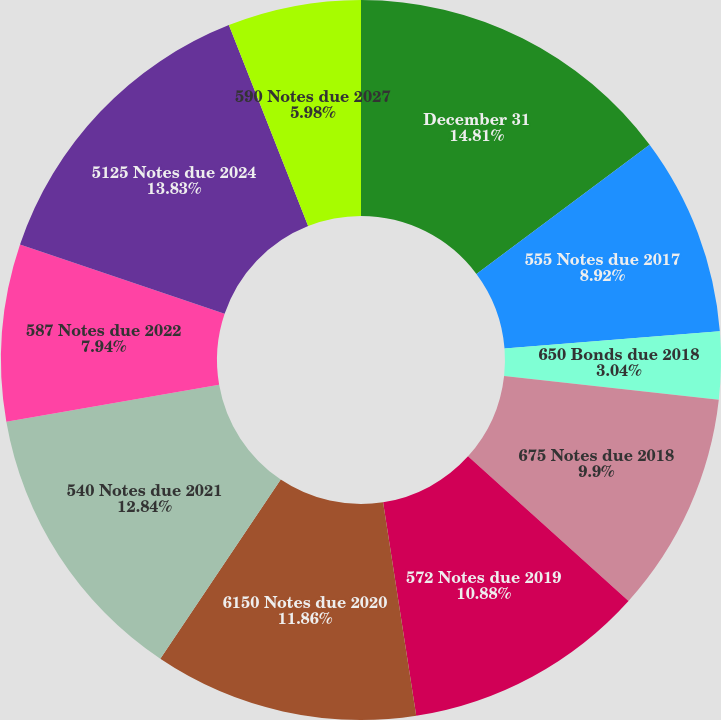Convert chart. <chart><loc_0><loc_0><loc_500><loc_500><pie_chart><fcel>December 31<fcel>555 Notes due 2017<fcel>650 Bonds due 2018<fcel>675 Notes due 2018<fcel>572 Notes due 2019<fcel>6150 Notes due 2020<fcel>540 Notes due 2021<fcel>587 Notes due 2022<fcel>5125 Notes due 2024<fcel>590 Notes due 2027<nl><fcel>14.8%<fcel>8.92%<fcel>3.04%<fcel>9.9%<fcel>10.88%<fcel>11.86%<fcel>12.84%<fcel>7.94%<fcel>13.82%<fcel>5.98%<nl></chart> 